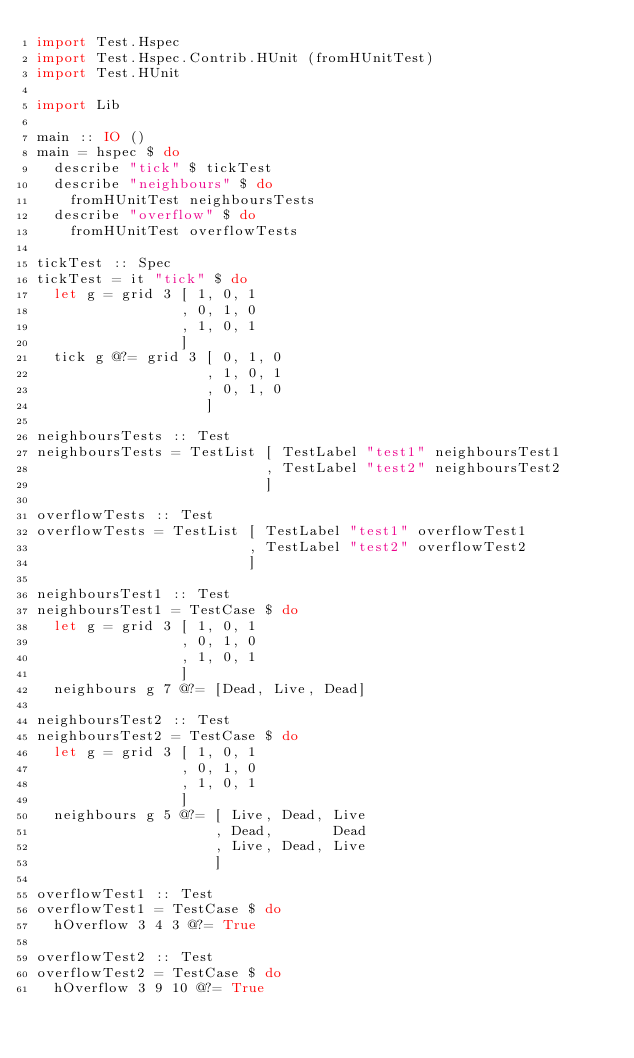<code> <loc_0><loc_0><loc_500><loc_500><_Haskell_>import Test.Hspec
import Test.Hspec.Contrib.HUnit (fromHUnitTest)
import Test.HUnit

import Lib

main :: IO ()
main = hspec $ do
  describe "tick" $ tickTest
  describe "neighbours" $ do
    fromHUnitTest neighboursTests
  describe "overflow" $ do
    fromHUnitTest overflowTests

tickTest :: Spec
tickTest = it "tick" $ do
  let g = grid 3 [ 1, 0, 1
                 , 0, 1, 0
                 , 1, 0, 1
                 ]
  tick g @?= grid 3 [ 0, 1, 0
                    , 1, 0, 1
                    , 0, 1, 0
                    ]

neighboursTests :: Test
neighboursTests = TestList [ TestLabel "test1" neighboursTest1
                           , TestLabel "test2" neighboursTest2
                           ]

overflowTests :: Test
overflowTests = TestList [ TestLabel "test1" overflowTest1
                         , TestLabel "test2" overflowTest2
                         ]

neighboursTest1 :: Test
neighboursTest1 = TestCase $ do
  let g = grid 3 [ 1, 0, 1
                 , 0, 1, 0
                 , 1, 0, 1
                 ]
  neighbours g 7 @?= [Dead, Live, Dead]

neighboursTest2 :: Test
neighboursTest2 = TestCase $ do
  let g = grid 3 [ 1, 0, 1
                 , 0, 1, 0
                 , 1, 0, 1
                 ]
  neighbours g 5 @?= [ Live, Dead, Live
                     , Dead,       Dead
                     , Live, Dead, Live
                     ]

overflowTest1 :: Test
overflowTest1 = TestCase $ do
  hOverflow 3 4 3 @?= True

overflowTest2 :: Test
overflowTest2 = TestCase $ do
  hOverflow 3 9 10 @?= True
</code> 